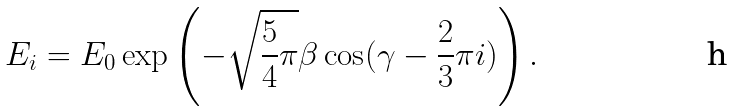<formula> <loc_0><loc_0><loc_500><loc_500>E _ { i } = E _ { 0 } \exp \left ( - \sqrt { \frac { 5 } { 4 } \pi } \beta \cos ( \gamma - \frac { 2 } { 3 } \pi i ) \right ) .</formula> 